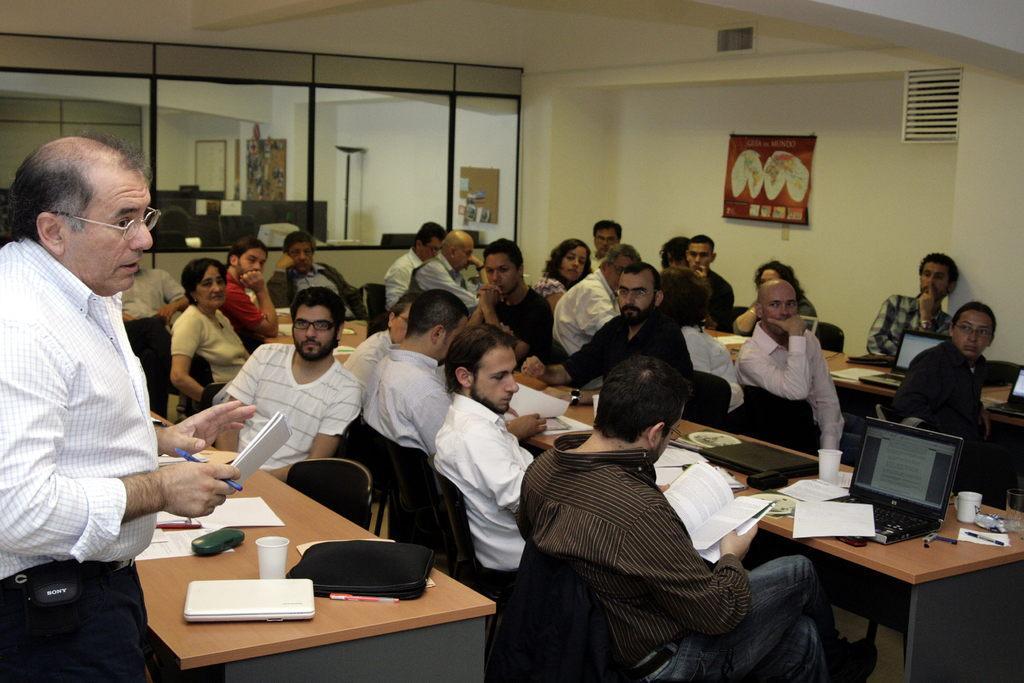Please provide a concise description of this image. There are many people sitting in this room. One person wearing a white shirt is standing. He is having a spectacles, book and a paper. In front of him there is a table. On the table there is a bag, glass, specs box, papers and laptop. In the background there is a poster and windows are over there. 